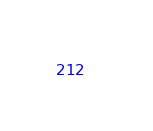<code> <loc_0><loc_0><loc_500><loc_500><_YAML_>
</code> 